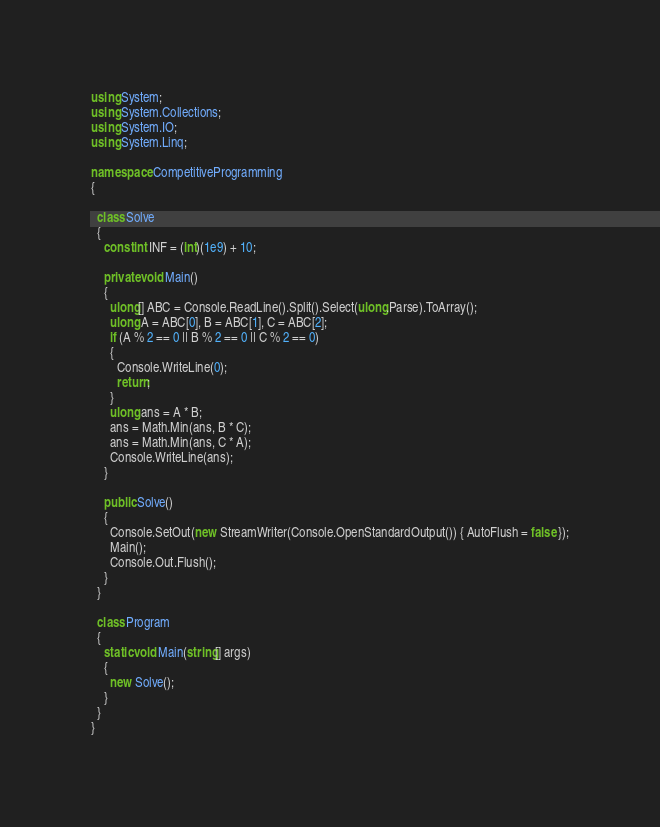<code> <loc_0><loc_0><loc_500><loc_500><_C#_>using System;
using System.Collections;
using System.IO;
using System.Linq;

namespace CompetitiveProgramming
{

  class Solve
  {
    const int INF = (int)(1e9) + 10;

    private void Main()
    {
      ulong[] ABC = Console.ReadLine().Split().Select(ulong.Parse).ToArray();
      ulong A = ABC[0], B = ABC[1], C = ABC[2];
      if (A % 2 == 0 || B % 2 == 0 || C % 2 == 0)
      {
        Console.WriteLine(0);
        return;
      }
      ulong ans = A * B;
      ans = Math.Min(ans, B * C);
      ans = Math.Min(ans, C * A);
      Console.WriteLine(ans);
    }

    public Solve()
    {
      Console.SetOut(new StreamWriter(Console.OpenStandardOutput()) { AutoFlush = false });
      Main();
      Console.Out.Flush();
    }
  }

  class Program
  {
    static void Main(string[] args)
    {
      new Solve();
    }
  }
}</code> 